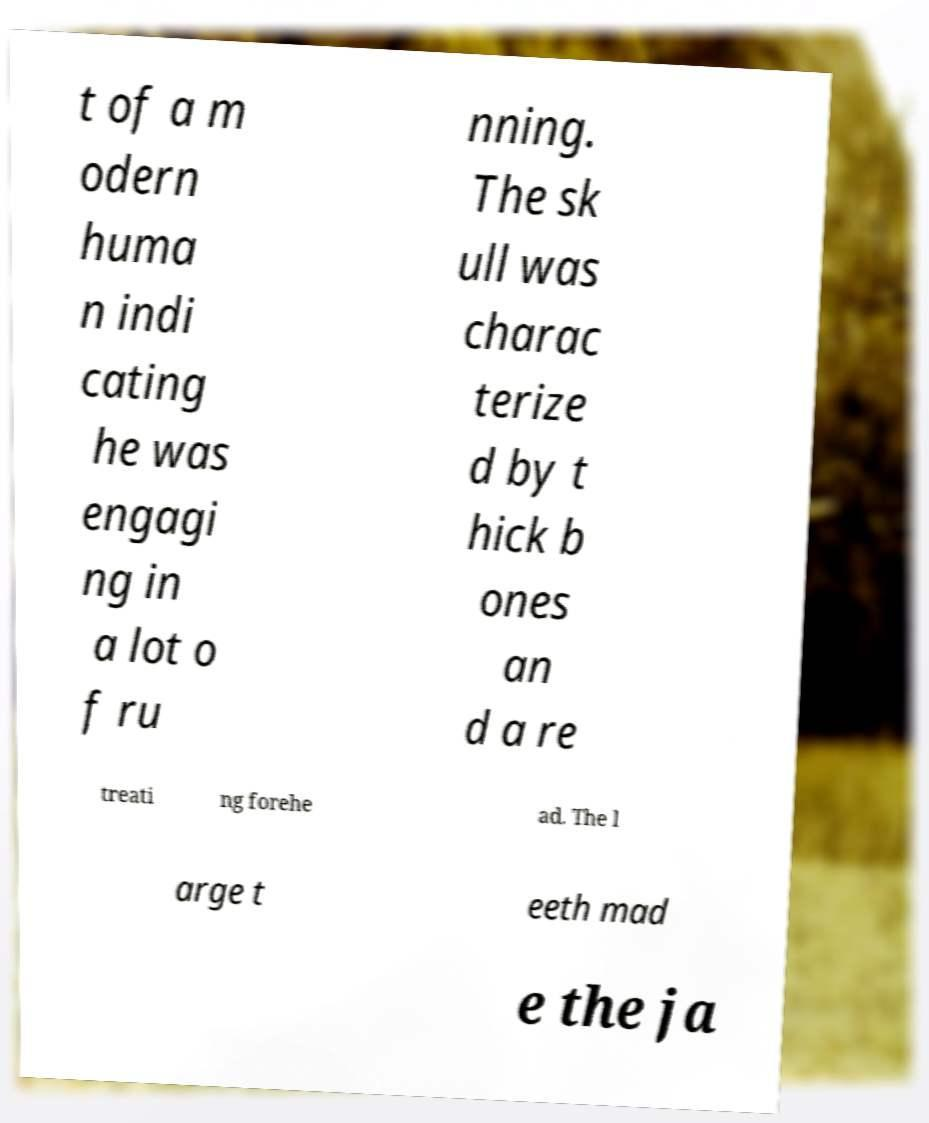Could you extract and type out the text from this image? t of a m odern huma n indi cating he was engagi ng in a lot o f ru nning. The sk ull was charac terize d by t hick b ones an d a re treati ng forehe ad. The l arge t eeth mad e the ja 